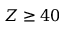<formula> <loc_0><loc_0><loc_500><loc_500>Z \geq 4 0</formula> 